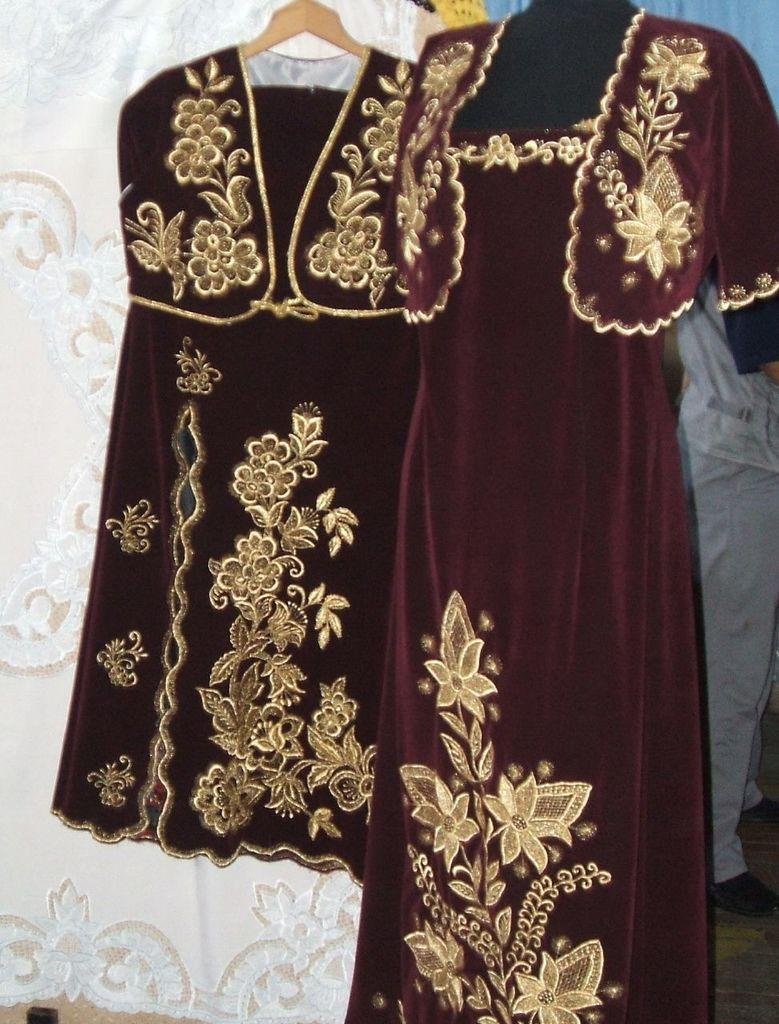What is hanging on the hanger in the image? There are dresses hanging on a hanger in the image. Can you describe the person standing on the right side of the image? Unfortunately, the provided facts do not give any information about the person's appearance or clothing. What type of plastic material is used to create the dinosaurs in the image? There are no dinosaurs present in the image, so it is not possible to determine the type of plastic material used. 